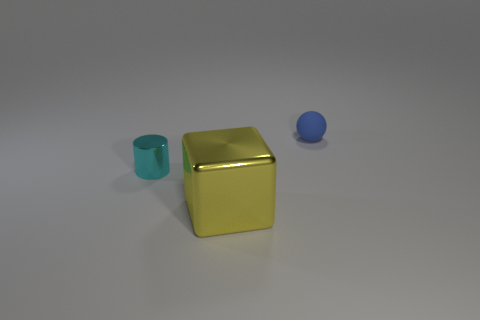Add 2 large yellow shiny cubes. How many objects exist? 5 Add 3 yellow blocks. How many yellow blocks are left? 4 Add 2 large metallic objects. How many large metallic objects exist? 3 Subtract 0 gray cylinders. How many objects are left? 3 Subtract all yellow cylinders. Subtract all purple spheres. How many cylinders are left? 1 Subtract all gray cubes. How many red spheres are left? 0 Subtract all large brown rubber things. Subtract all tiny rubber spheres. How many objects are left? 2 